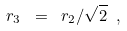<formula> <loc_0><loc_0><loc_500><loc_500>r _ { 3 } \ = \ r _ { 2 } / \sqrt { 2 } \ ,</formula> 